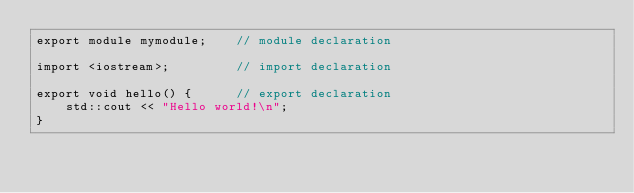<code> <loc_0><loc_0><loc_500><loc_500><_C++_>export module mymodule;    // module declaration

import <iostream>;         // import declaration
 
export void hello() {      // export declaration
    std::cout << "Hello world!\n";
}

</code> 